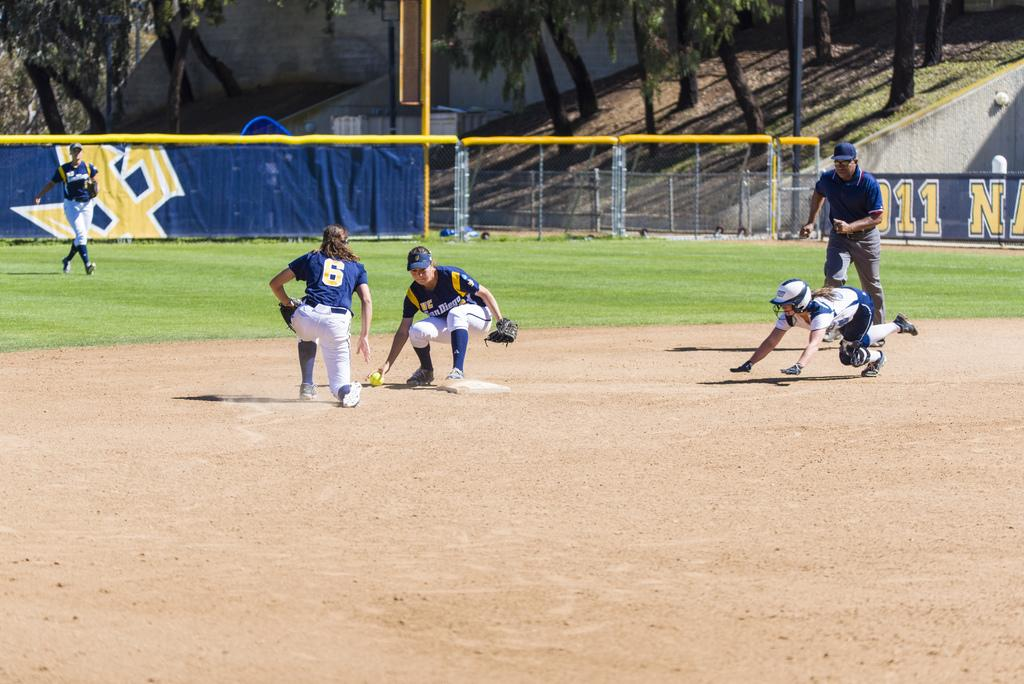Provide a one-sentence caption for the provided image. A San Diego girls softball team is in the middle of a game on a bright sunny day. 